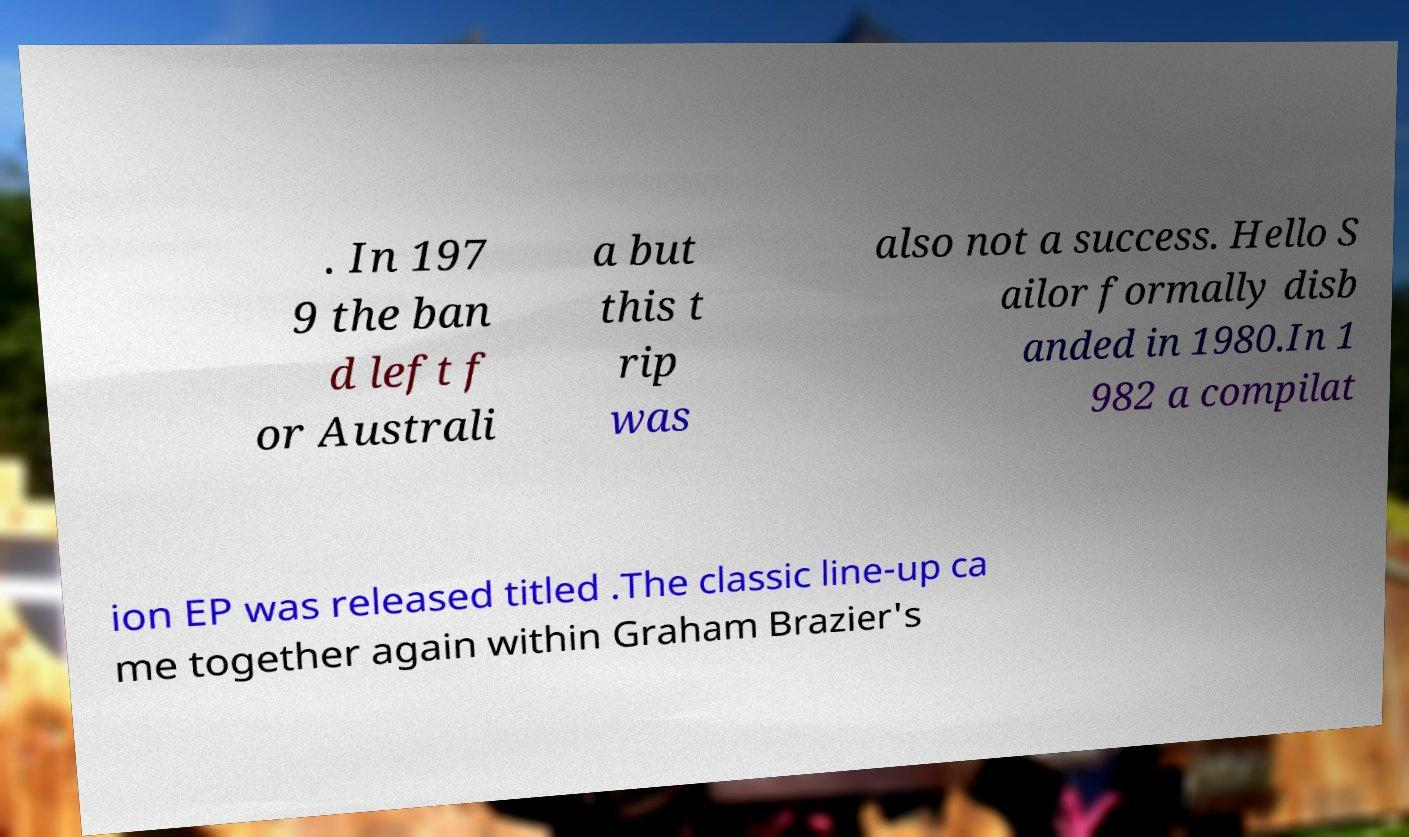What messages or text are displayed in this image? I need them in a readable, typed format. . In 197 9 the ban d left f or Australi a but this t rip was also not a success. Hello S ailor formally disb anded in 1980.In 1 982 a compilat ion EP was released titled .The classic line-up ca me together again within Graham Brazier's 